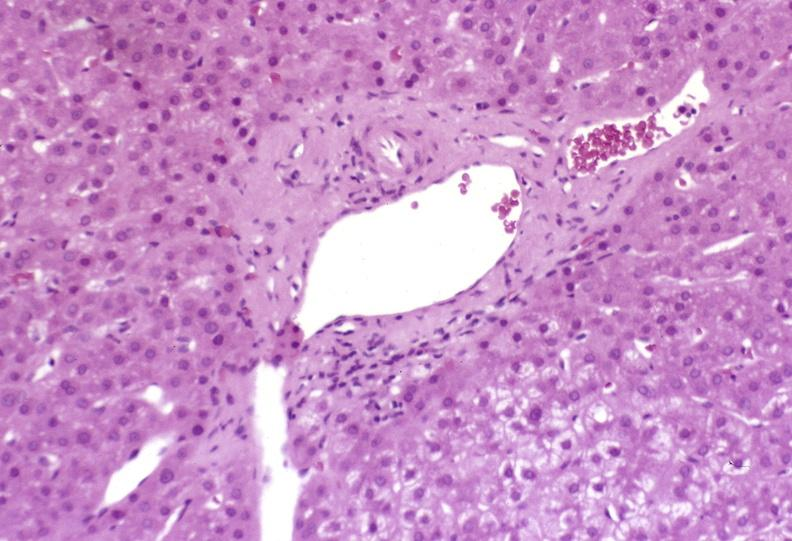s malignant histiocytosis present?
Answer the question using a single word or phrase. No 